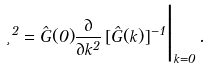Convert formula to latex. <formula><loc_0><loc_0><loc_500><loc_500>\xi ^ { 2 } = \hat { G } ( { 0 } ) \frac { \partial } { \partial k ^ { 2 } } \, [ \hat { G } ( { k } ) ] ^ { - 1 } \Big | _ { k = 0 } \, .</formula> 